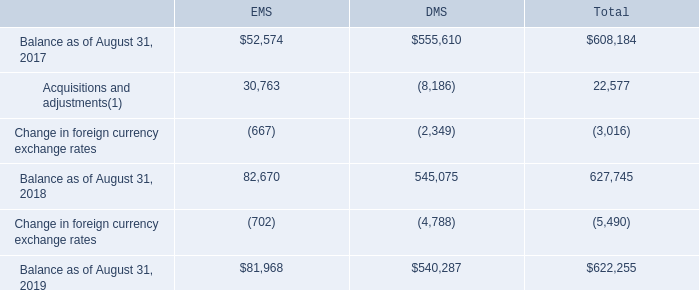6. Goodwill and Other Intangible Assets
The Company completed its annual impairment test for goodwill and indefinite-lived intangible assets during the fourth quarter of fiscal year 2019 and determined the fair values of the reporting units and the indefinite-lived intangible assets were in excess of the carrying values and that no impairment existed as of the date of the impairment test.
The following table presents the changes in goodwill allocated to the Company’s reportable segments, Electronics Manufacturing Services (“EMS”) and Diversified Manufacturing Services (“DMS”), during the fiscal years ended August 31, 2019 and 2018 (in thousands):
(1) Includes $8.2 million of goodwill reallocated between DMS and EMS during fiscal year 2018.
What did Acquisitions and adjustments include? $8.2 million of goodwill reallocated between dms and ems during fiscal year 2018. What was the Balance as of August 31, 2017 in EMS?
Answer scale should be: thousand. $52,574. Which years does the company provide information for changes in goodwill allocated to the Company's reportable segments? 2018, 2019. What is the difference in Acquisitions and adjustments in fiscal 2018 between EMS and DMS?
Answer scale should be: thousand. 30,763-(-8,186)
Answer: 38949. What was the balance of EMS as in 2018 as a percentage of the total balance at the end of fiscal 2018?
Answer scale should be: percent. 82,670/627,745
Answer: 13.17. What was the percentage change in total balance between 2018 and 2019?
Answer scale should be: percent. ($622,255-627,745)/627,745
Answer: -0.87. 